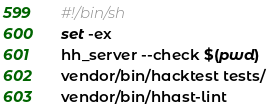Convert code to text. <code><loc_0><loc_0><loc_500><loc_500><_Bash_>#!/bin/sh
set -ex
hh_server --check $(pwd)
vendor/bin/hacktest tests/
vendor/bin/hhast-lint
</code> 